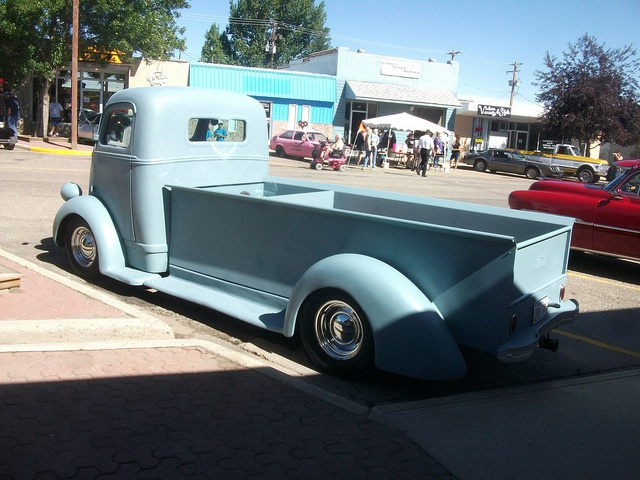Describe the objects in this image and their specific colors. I can see truck in darkgreen, black, lightblue, blue, and gray tones, car in darkgreen, maroon, black, brown, and gray tones, car in darkgreen, black, and gray tones, truck in darkgreen, black, darkgray, gray, and lightgray tones, and car in darkgreen, brown, gray, lavender, and darkgray tones in this image. 